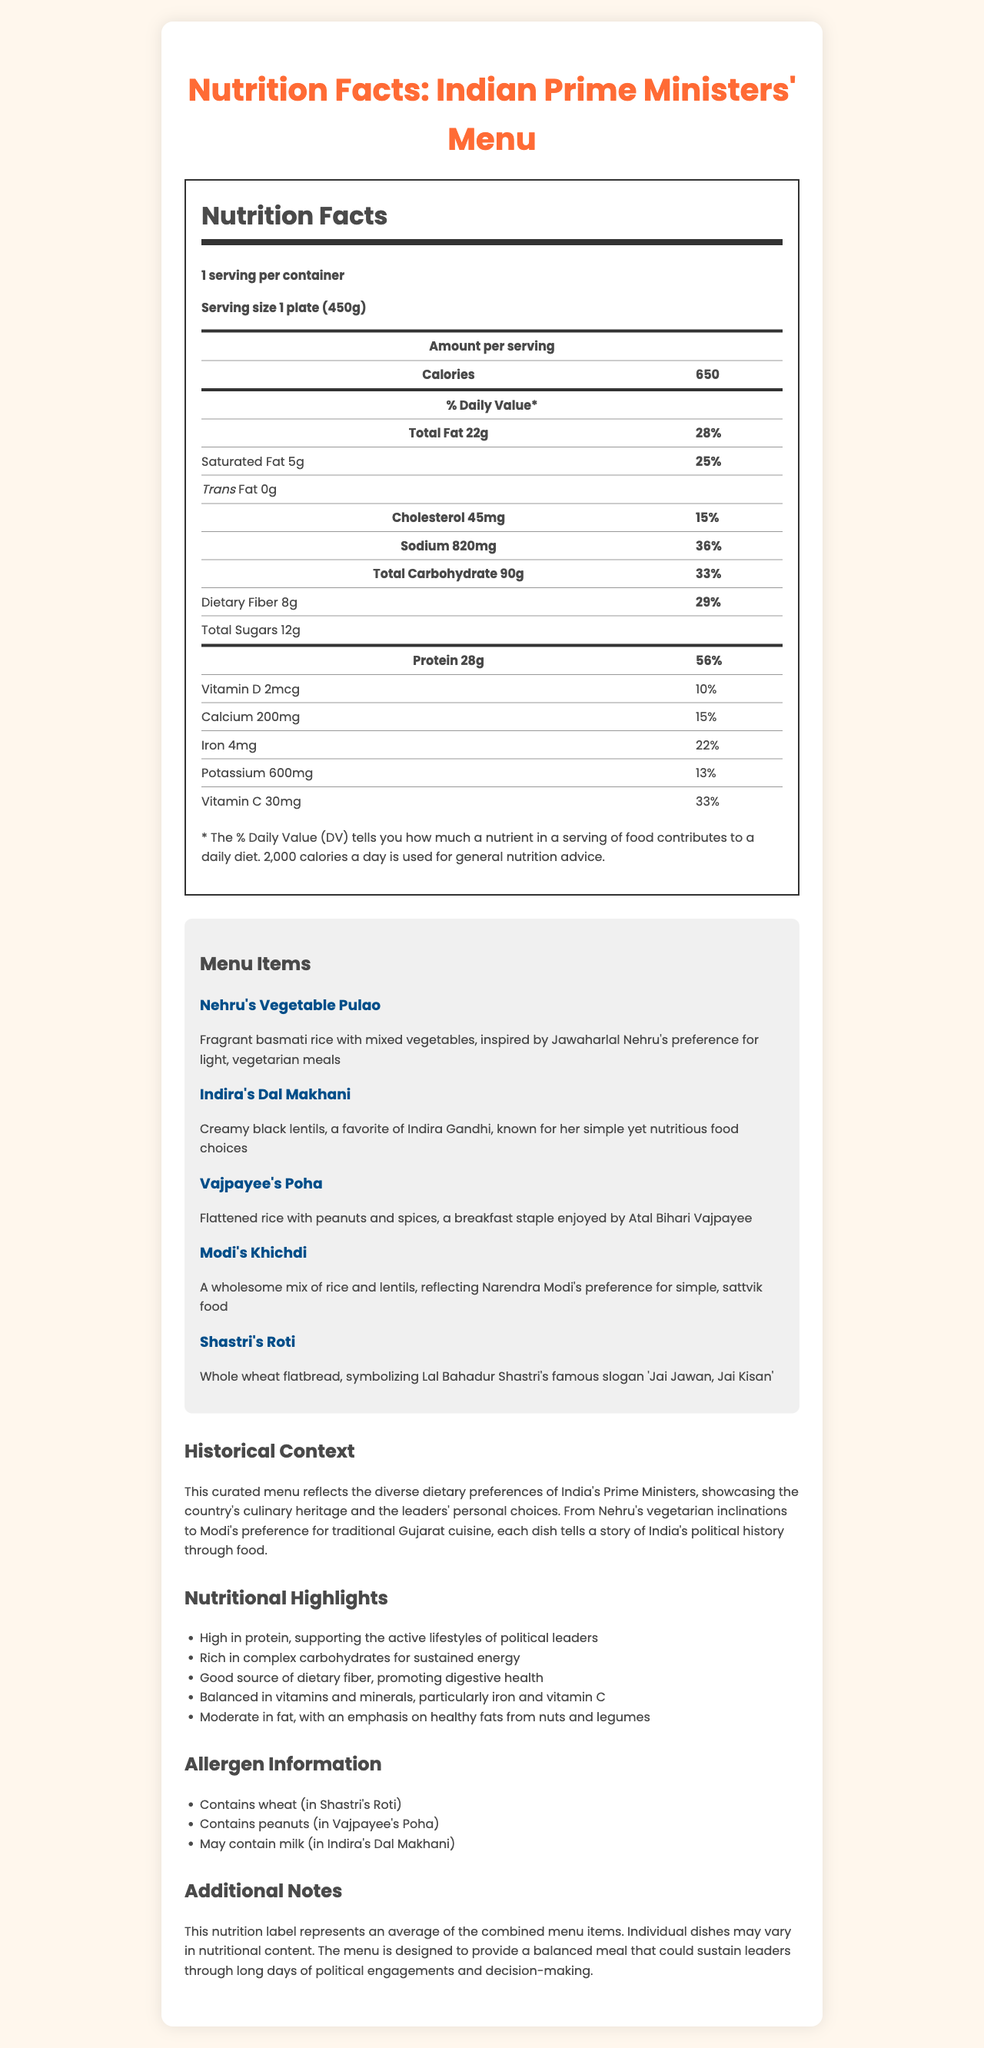What is the serving size for the curated menu? The document states that the serving size is "1 plate (450g)".
Answer: 1 plate (450g) How many calories are in one serving of the menu? The document specifies that there are 650 calories in one serving.
Answer: 650 What is the daily value percentage of total fat in the menu? According to the document, the daily value percentage for total fat is 28%.
Answer: 28% How much dietary fiber does one serving contain? The document mentions that one serving contains 8g of dietary fiber.
Answer: 8g Which dish in the menu is inspired by Jawaharlal Nehru? The menu items section describes "Nehru's Vegetable Pulao" as inspired by Jawaharlal Nehru.
Answer: Nehru's Vegetable Pulao What is the daily value percentage of sodium? A. 15% B. 28% C. 36% D. 50% According to the document, the daily value percentage for sodium is 36%.
Answer: C. 36% Which vitamin is provided in the highest daily value percentage? A. Vitamin D B. Vitamin C C. Calcium D. Vitamin A Vitamin C is provided at a daily value percentage of 33%, which is the highest among the vitamins listed.
Answer: B. Vitamin C Does the menu contain any peanuts? The allergen information section mentions that Vajpayee's Poha contains peanuts.
Answer: Yes Is the menu high in protein? The nutritional highlights section states that the menu is high in protein, supporting the active lifestyles of political leaders.
Answer: Yes Summarize the document. The document offers a nutritional overview of a menu inspired by Indian Prime Ministers, including calorie content, macronutrient values, vitamins, historical context, and allergen information.
Answer: The document provides a detailed nutritional breakdown of a curated menu inspired by the dietary habits of various Indian Prime Ministers, featuring macronutrient balances and key vitamins. It includes a historical context, nutritional highlights, allergen information, and individual descriptions of the dishes. How much cholesterol is in one serving of the menu? The document specifies that there are 45mg of cholesterol in one serving.
Answer: 45mg Is there any trans fat in the menu? The document lists the amount of trans fat as 0g.
Answer: No What percentage of daily protein value does one serving provide? According to the document, one serving provides 56% of the daily value for protein.
Answer: 56% Which dish reflects Narendra Modi's eating preferences? The menu items section describes "Modi's Khichdi" as reflecting Narendra Modi's preference for simple, sattvik food.
Answer: Modi's Khichdi What is the historical context provided in the document? The historical context section explains that the menu reflects the diverse dietary preferences of India's Prime Ministers and tells a story of India's political history through food.
Answer: This curated menu reflects the diverse dietary preferences of India's Prime Ministers, showcasing the country's culinary heritage and the leaders' personal choices. Which nutrient is present in the lowest amount of daily value percentage? Vitamin D, with a daily value percentage of 10%, is the lowest among the listed nutrients.
Answer: Vitamin D What is the main source of complex carbohydrates mentioned in the highlights? The nutritional highlights section mentions that the menu is rich in complex carbohydrates for sustained energy but does not specify the exact sources.
Answer: Not explicitly mentioned 